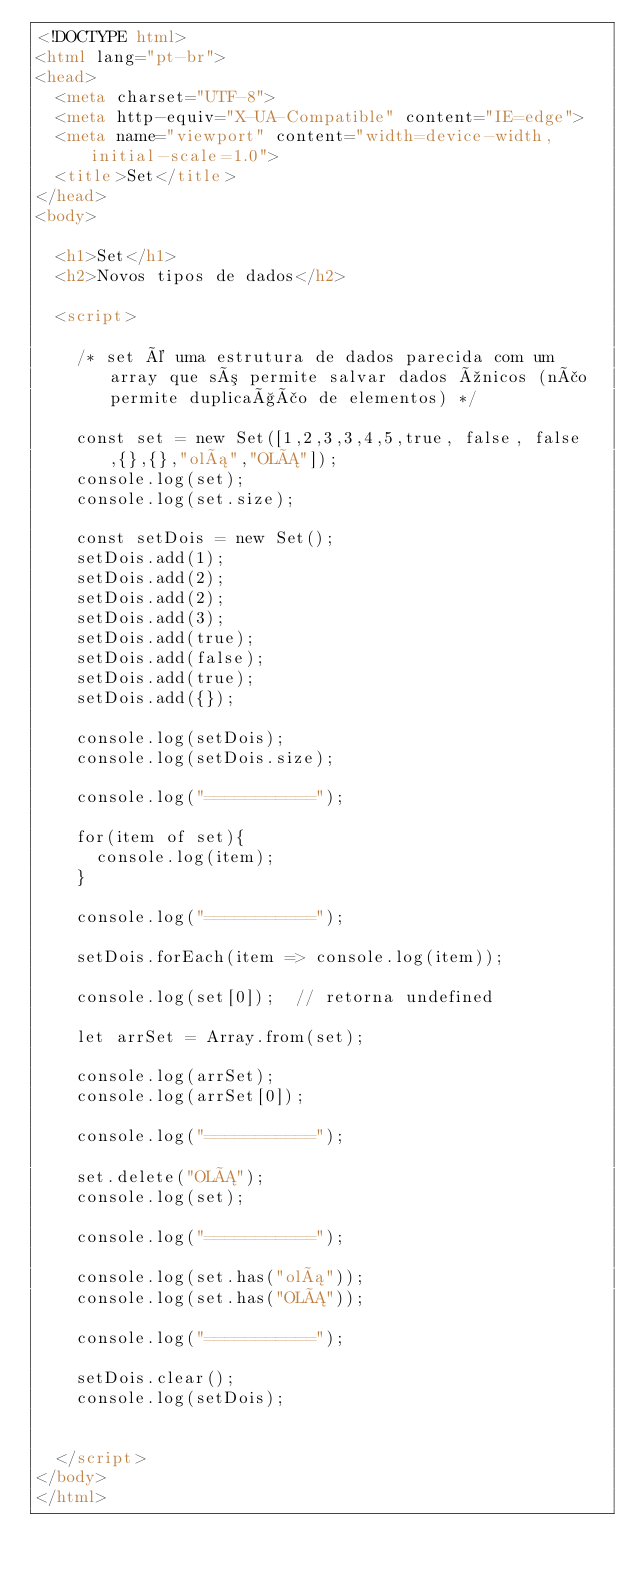Convert code to text. <code><loc_0><loc_0><loc_500><loc_500><_HTML_><!DOCTYPE html>
<html lang="pt-br">
<head>
  <meta charset="UTF-8">
  <meta http-equiv="X-UA-Compatible" content="IE=edge">
  <meta name="viewport" content="width=device-width, initial-scale=1.0">
  <title>Set</title>
</head>
<body>

  <h1>Set</h1>
  <h2>Novos tipos de dados</h2>

  <script>

    /* set é uma estrutura de dados parecida com um array que só permite salvar dados únicos (não permite duplicação de elementos) */

    const set = new Set([1,2,3,3,4,5,true, false, false,{},{},"olá","OLÁ"]);
    console.log(set);
    console.log(set.size);

    const setDois = new Set();
    setDois.add(1);
    setDois.add(2);
    setDois.add(2);
    setDois.add(3);
    setDois.add(true);
    setDois.add(false);
    setDois.add(true);
    setDois.add({});

    console.log(setDois);
    console.log(setDois.size);

    console.log("===========");

    for(item of set){
      console.log(item);
    }

    console.log("===========");

    setDois.forEach(item => console.log(item));

    console.log(set[0]);  // retorna undefined

    let arrSet = Array.from(set);

    console.log(arrSet);
    console.log(arrSet[0]);

    console.log("===========");

    set.delete("OLÁ");
    console.log(set);

    console.log("===========");

    console.log(set.has("olá"));
    console.log(set.has("OLÁ"));

    console.log("===========");

    setDois.clear();
    console.log(setDois);


  </script>
</body>
</html></code> 